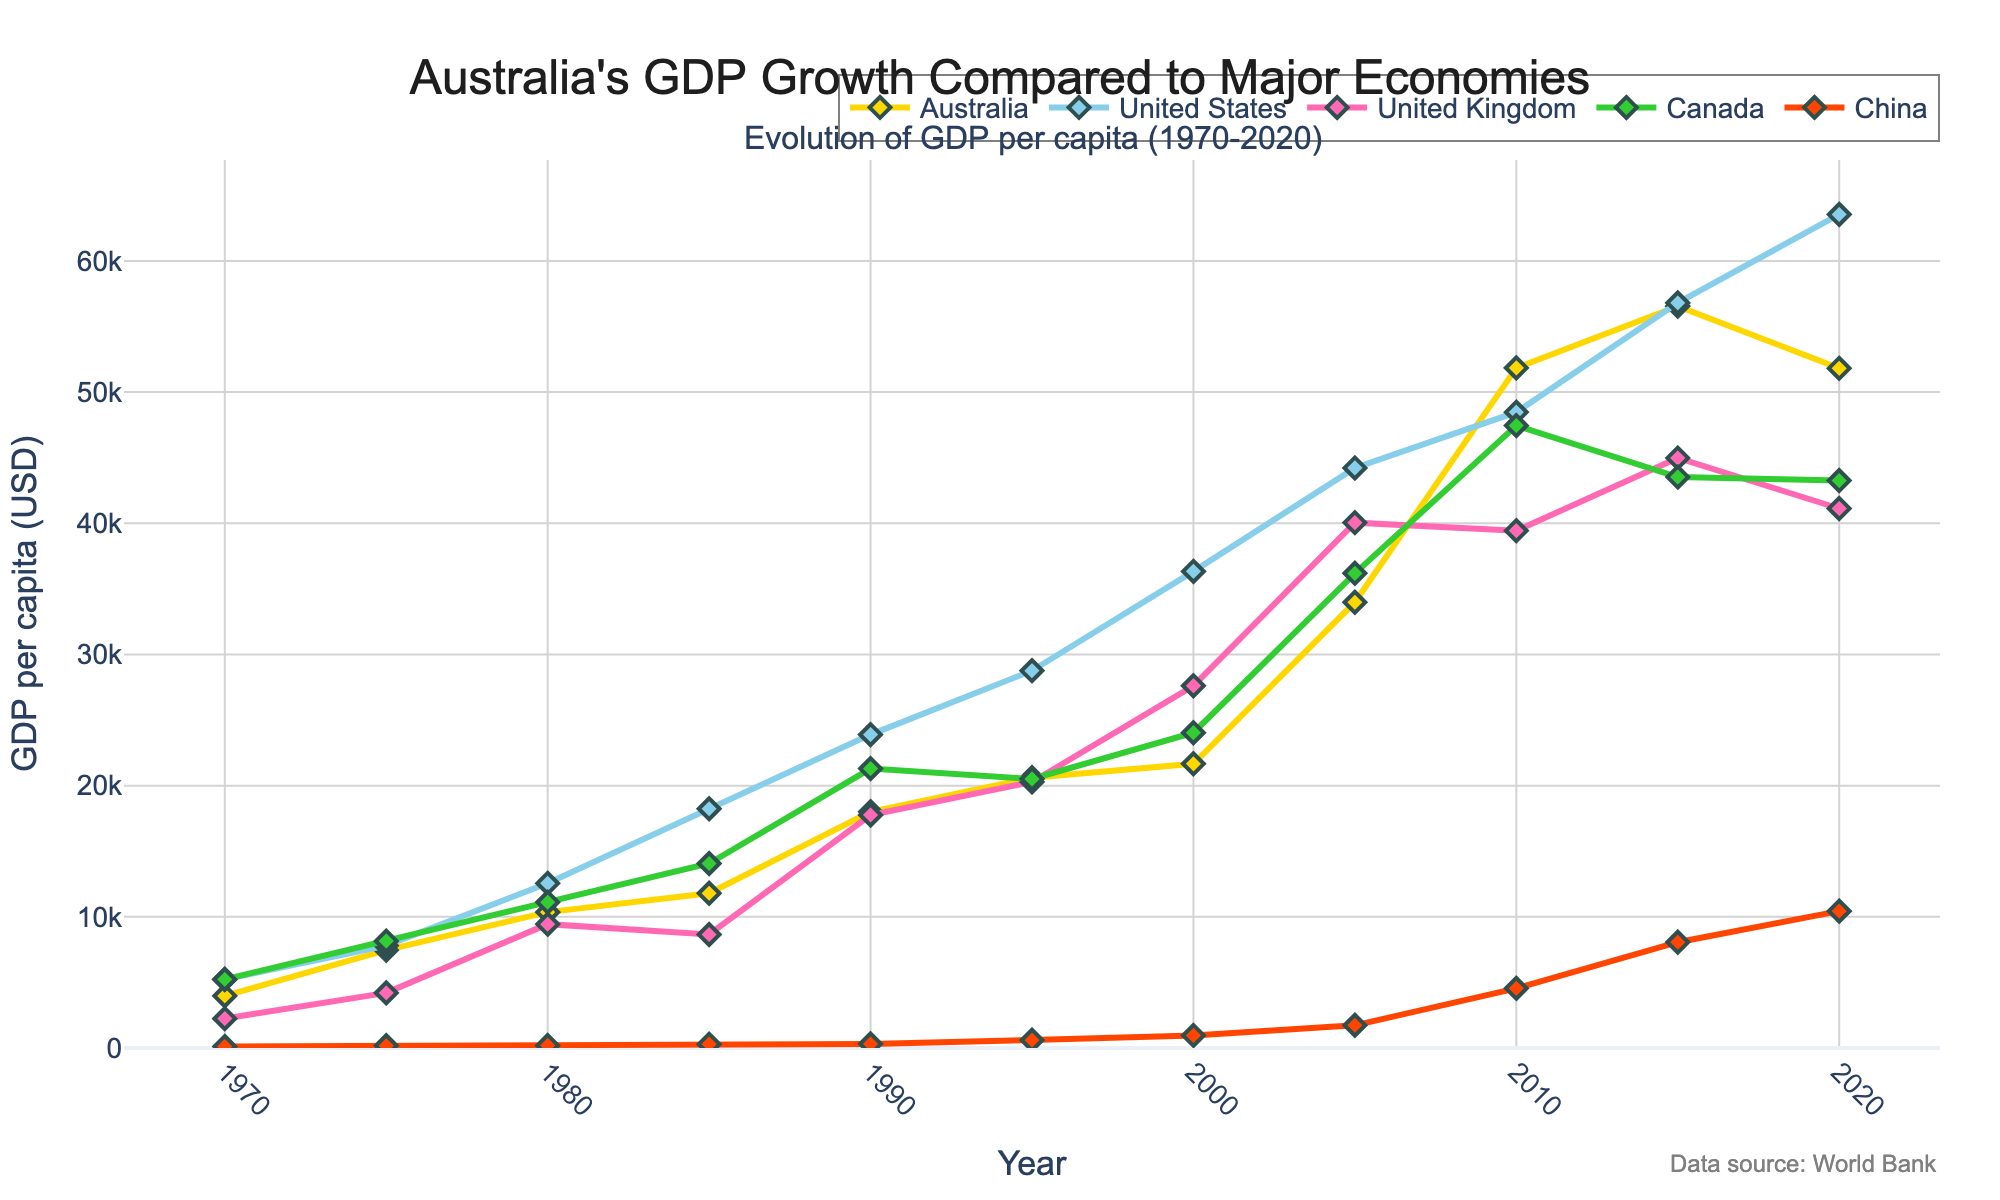What was the GDP per capita of Australia in 2020 compared to China in the same year? Locate Australia's and China's GDP per capita values for the year 2020 in the plot. Australia's GDP per capita in 2020 is around 51,812 USD, while China's is approximately 10,435 USD.
Answer: Australia's GDP per capita was significantly higher than China's in 2020 How did Australia's GDP per capita evolve between 1970 and 2020? Observe the trend of the line representing Australia from 1970 to 2020. The GDP per capita shows a steady increase with some fluctuation post-2015. Overall, Australia’s GDP per capita grew from around 3,975 USD in 1970 to approximately 51,812 USD in 2020.
Answer: It increased significantly over the five decades Which country had the highest GDP per capita in 2015, and how does Australia's GDP per capita that year compare? Find and compare the GDP per capita figures of the countries in 2015. The United States had the highest GDP per capita in 2015 with around 56,803 USD, while Australia's GDP per capita was around 56,554 USD, very close but slightly less.
Answer: United States; Australia's was slightly less What was the average GDP per capita of Australia, Canada, and the United Kingdom in 1990? Locate the GDP per capita values for Australia, Canada, and the United Kingdom in 1990: Australia (18,007 USD), Canada (21,302 USD), and the United Kingdom (17,762 USD). Calculate the average: (18,007 + 21,302 + 17,762) / 3.
Answer: 19,024 USD Which country showed the steepest increase in GDP per capita from 2000 to 2010? Compare the slopes of the lines from 2000 to 2010 among the countries. China's line shows the steepest increase, moving from around 959 USD in 2000 to about 4,550 USD in 2010.
Answer: China Between Australia and Canada, which country had a higher GDP per capita in 1980, and what is the difference? Check the GDP per capita values for Australia and Canada in 1980: Australia (10,358 USD) and Canada (11,116 USD). Calculate the difference: 11,116 - 10,358.
Answer: Canada; 758 USD In what year did Australia surpass the United Kingdom in GDP per capita? Track the lines for Australia and the United Kingdom. Australia surpasses the United Kingdom around the year 1975.
Answer: Around 1975 How does the GDP per capita growth trend of China compare to Australia from 1970 to 2020? Examine how the GDP per capita values of China and Australia changed over the 50-year period. China's GDP per capita started low and showed a rapid increase especially post-2000, while Australia's growth was steady but less abrupt.
Answer: China's growth rate was faster, particularly starting from the 2000s Which country had the lowest GDP per capita in 2005 and what was Australia's position compared to it? Identify the lowest GDP per capita in 2005 (China, approximately 1,731 USD). Australia's GDP per capita in 2005 was around 33,983 USD, significantly higher.
Answer: China; Australia was much higher 